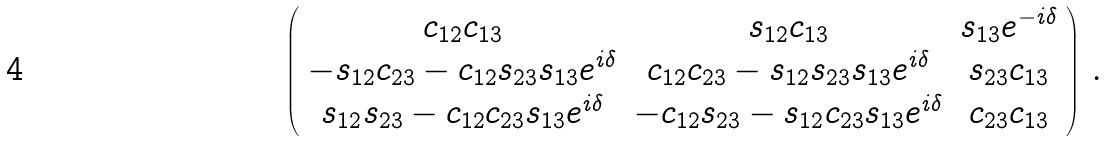Convert formula to latex. <formula><loc_0><loc_0><loc_500><loc_500>\left ( \begin{array} { c c c } c _ { 1 2 } c _ { 1 3 } & s _ { 1 2 } c _ { 1 3 } & s _ { 1 3 } e ^ { - i \delta } \\ - s _ { 1 2 } c _ { 2 3 } - c _ { 1 2 } s _ { 2 3 } s _ { 1 3 } e ^ { i \delta } & c _ { 1 2 } c _ { 2 3 } - s _ { 1 2 } s _ { 2 3 } s _ { 1 3 } e ^ { i \delta } & s _ { 2 3 } c _ { 1 3 } \\ s _ { 1 2 } s _ { 2 3 } - c _ { 1 2 } c _ { 2 3 } s _ { 1 3 } e ^ { i \delta } & - c _ { 1 2 } s _ { 2 3 } - s _ { 1 2 } c _ { 2 3 } s _ { 1 3 } e ^ { i \delta } & c _ { 2 3 } c _ { 1 3 } \end{array} \right ) \, .</formula> 